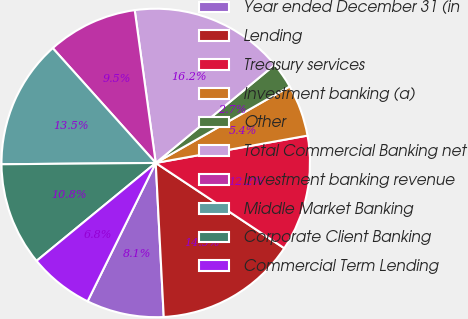Convert chart to OTSL. <chart><loc_0><loc_0><loc_500><loc_500><pie_chart><fcel>Year ended December 31 (in<fcel>Lending<fcel>Treasury services<fcel>Investment banking (a)<fcel>Other<fcel>Total Commercial Banking net<fcel>Investment banking revenue<fcel>Middle Market Banking<fcel>Corporate Client Banking<fcel>Commercial Term Lending<nl><fcel>8.11%<fcel>14.85%<fcel>12.16%<fcel>5.42%<fcel>2.72%<fcel>16.2%<fcel>9.46%<fcel>13.5%<fcel>10.81%<fcel>6.77%<nl></chart> 